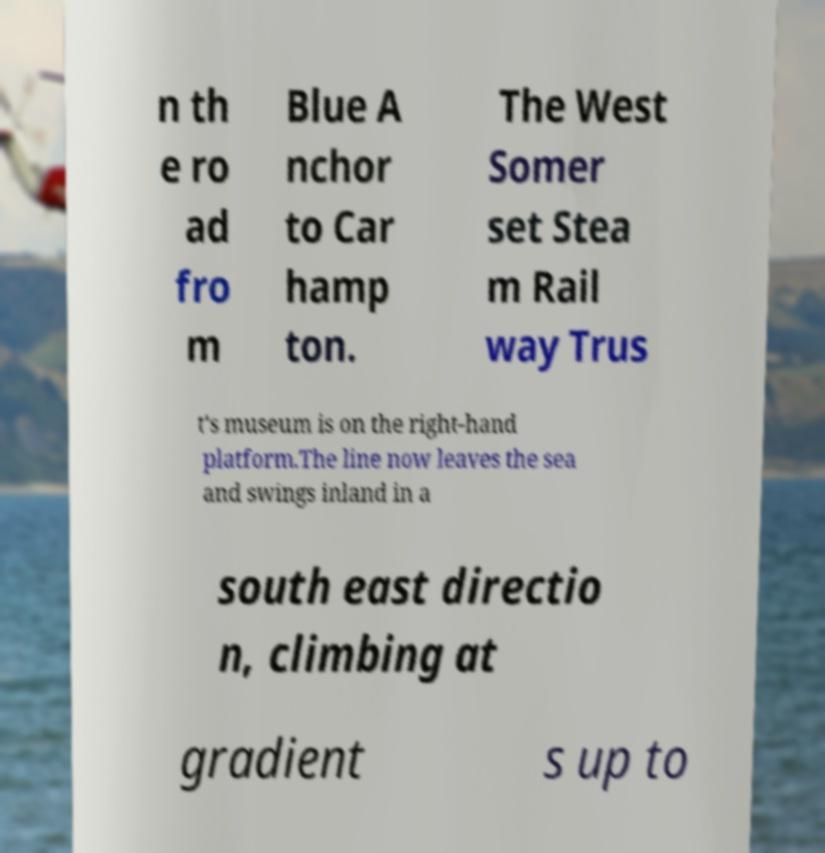What messages or text are displayed in this image? I need them in a readable, typed format. n th e ro ad fro m Blue A nchor to Car hamp ton. The West Somer set Stea m Rail way Trus t's museum is on the right-hand platform.The line now leaves the sea and swings inland in a south east directio n, climbing at gradient s up to 